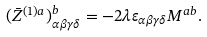Convert formula to latex. <formula><loc_0><loc_0><loc_500><loc_500>( \bar { Z } ^ { ( 1 ) a } ) _ { \alpha \beta \gamma \delta } ^ { b } = - 2 \lambda \varepsilon _ { \alpha \beta \gamma \delta } M ^ { a b } .</formula> 